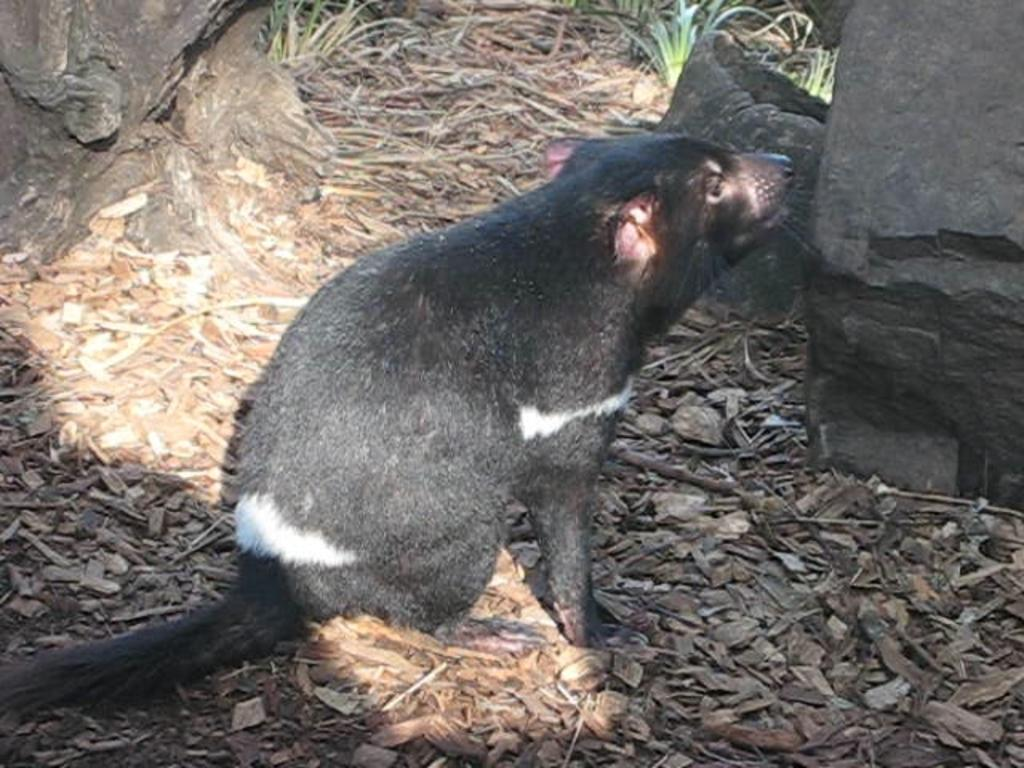What type of animal is in the image? There is an animal in the image, but its specific type cannot be determined from the provided facts. What color is the animal in the image? The animal is black in color. What can be seen on the right side of the image? There are stones on the right side of the image. What type of vegetation is at the top of the image? There are green plants at the top of the image. What type of crime is being committed in the image? There is no indication of any crime being committed in the image. The image features an animal, stones, and green plants, but no criminal activity is depicted. 